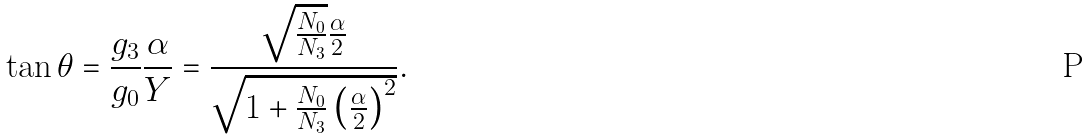Convert formula to latex. <formula><loc_0><loc_0><loc_500><loc_500>\tan \theta = \frac { g _ { 3 } } { g _ { 0 } } \frac { \alpha } { Y } = \frac { \sqrt { \frac { N _ { 0 } } { N _ { 3 } } } \frac { \alpha } { 2 } } { \sqrt { 1 + \frac { N _ { 0 } } { N _ { 3 } } \left ( \frac { \alpha } { 2 } \right ) ^ { 2 } } } .</formula> 